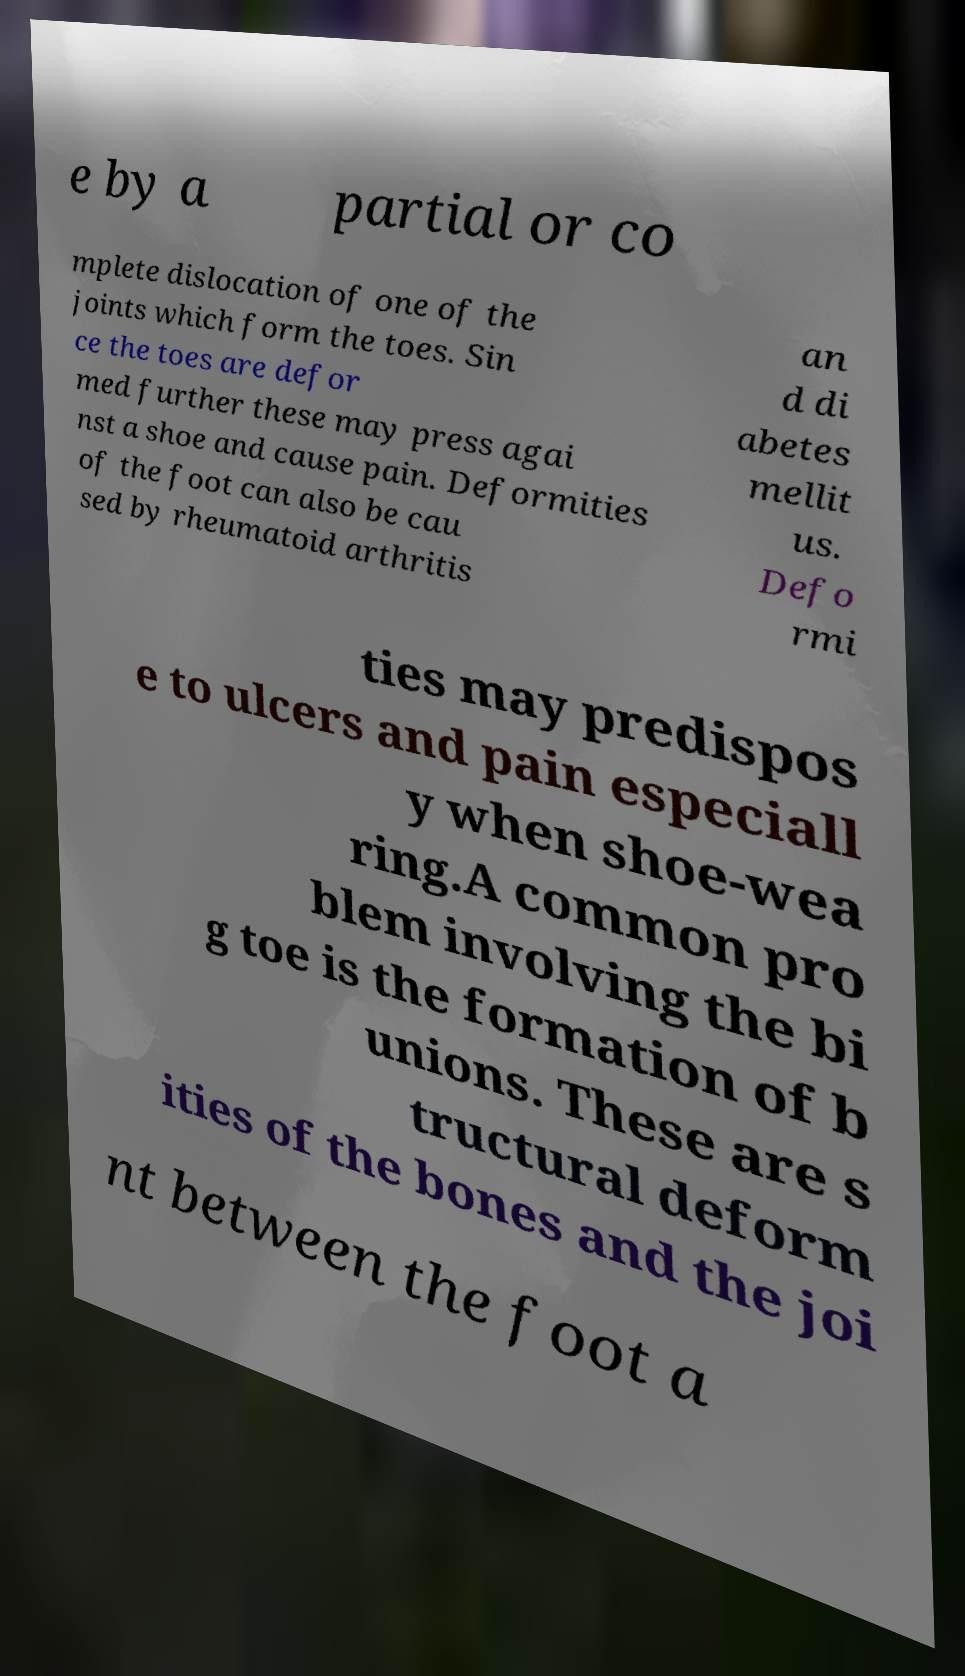Could you extract and type out the text from this image? e by a partial or co mplete dislocation of one of the joints which form the toes. Sin ce the toes are defor med further these may press agai nst a shoe and cause pain. Deformities of the foot can also be cau sed by rheumatoid arthritis an d di abetes mellit us. Defo rmi ties may predispos e to ulcers and pain especiall y when shoe-wea ring.A common pro blem involving the bi g toe is the formation of b unions. These are s tructural deform ities of the bones and the joi nt between the foot a 